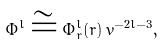<formula> <loc_0><loc_0><loc_500><loc_500>\Phi ^ { l } \cong \Phi _ { r } ^ { l } ( r ) \, v ^ { - 2 l - 3 } ,</formula> 